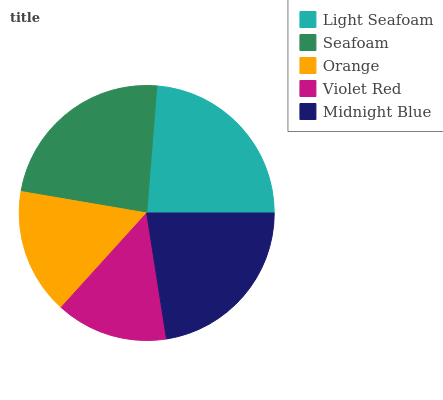Is Violet Red the minimum?
Answer yes or no. Yes. Is Light Seafoam the maximum?
Answer yes or no. Yes. Is Seafoam the minimum?
Answer yes or no. No. Is Seafoam the maximum?
Answer yes or no. No. Is Light Seafoam greater than Seafoam?
Answer yes or no. Yes. Is Seafoam less than Light Seafoam?
Answer yes or no. Yes. Is Seafoam greater than Light Seafoam?
Answer yes or no. No. Is Light Seafoam less than Seafoam?
Answer yes or no. No. Is Midnight Blue the high median?
Answer yes or no. Yes. Is Midnight Blue the low median?
Answer yes or no. Yes. Is Violet Red the high median?
Answer yes or no. No. Is Seafoam the low median?
Answer yes or no. No. 